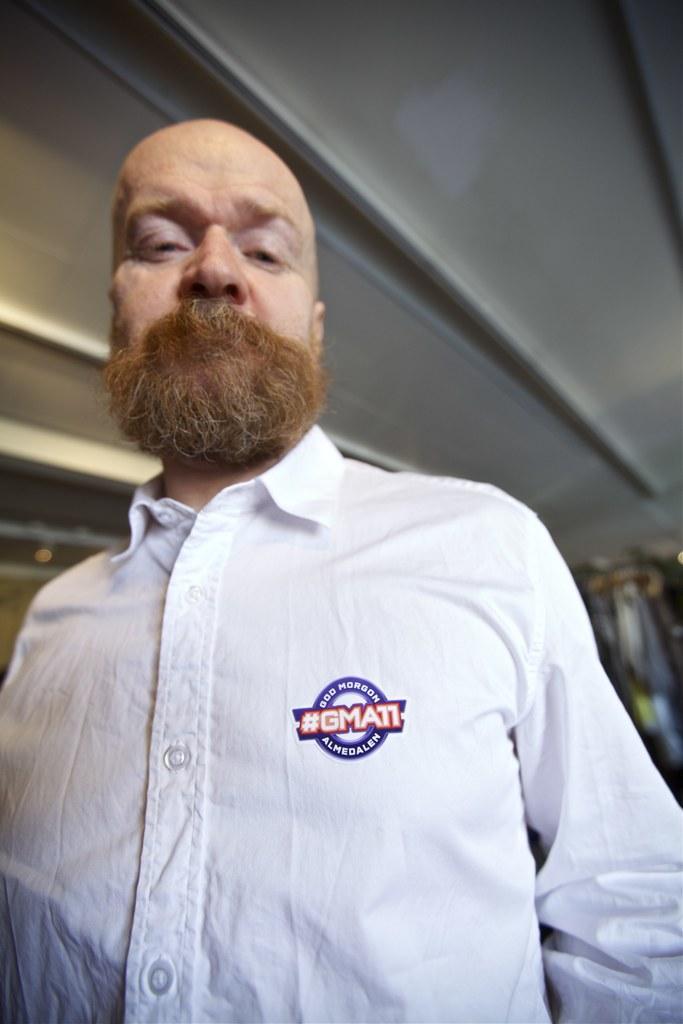In one or two sentences, can you explain what this image depicts? In this image, we can see a person. We can see the roof and the blurred background. 